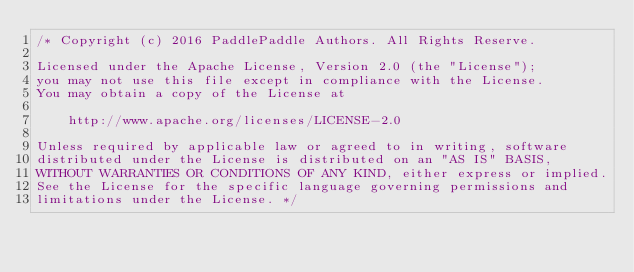Convert code to text. <code><loc_0><loc_0><loc_500><loc_500><_C_>/* Copyright (c) 2016 PaddlePaddle Authors. All Rights Reserve.

Licensed under the Apache License, Version 2.0 (the "License");
you may not use this file except in compliance with the License.
You may obtain a copy of the License at

    http://www.apache.org/licenses/LICENSE-2.0

Unless required by applicable law or agreed to in writing, software
distributed under the License is distributed on an "AS IS" BASIS,
WITHOUT WARRANTIES OR CONDITIONS OF ANY KIND, either express or implied.
See the License for the specific language governing permissions and
limitations under the License. */
</code> 